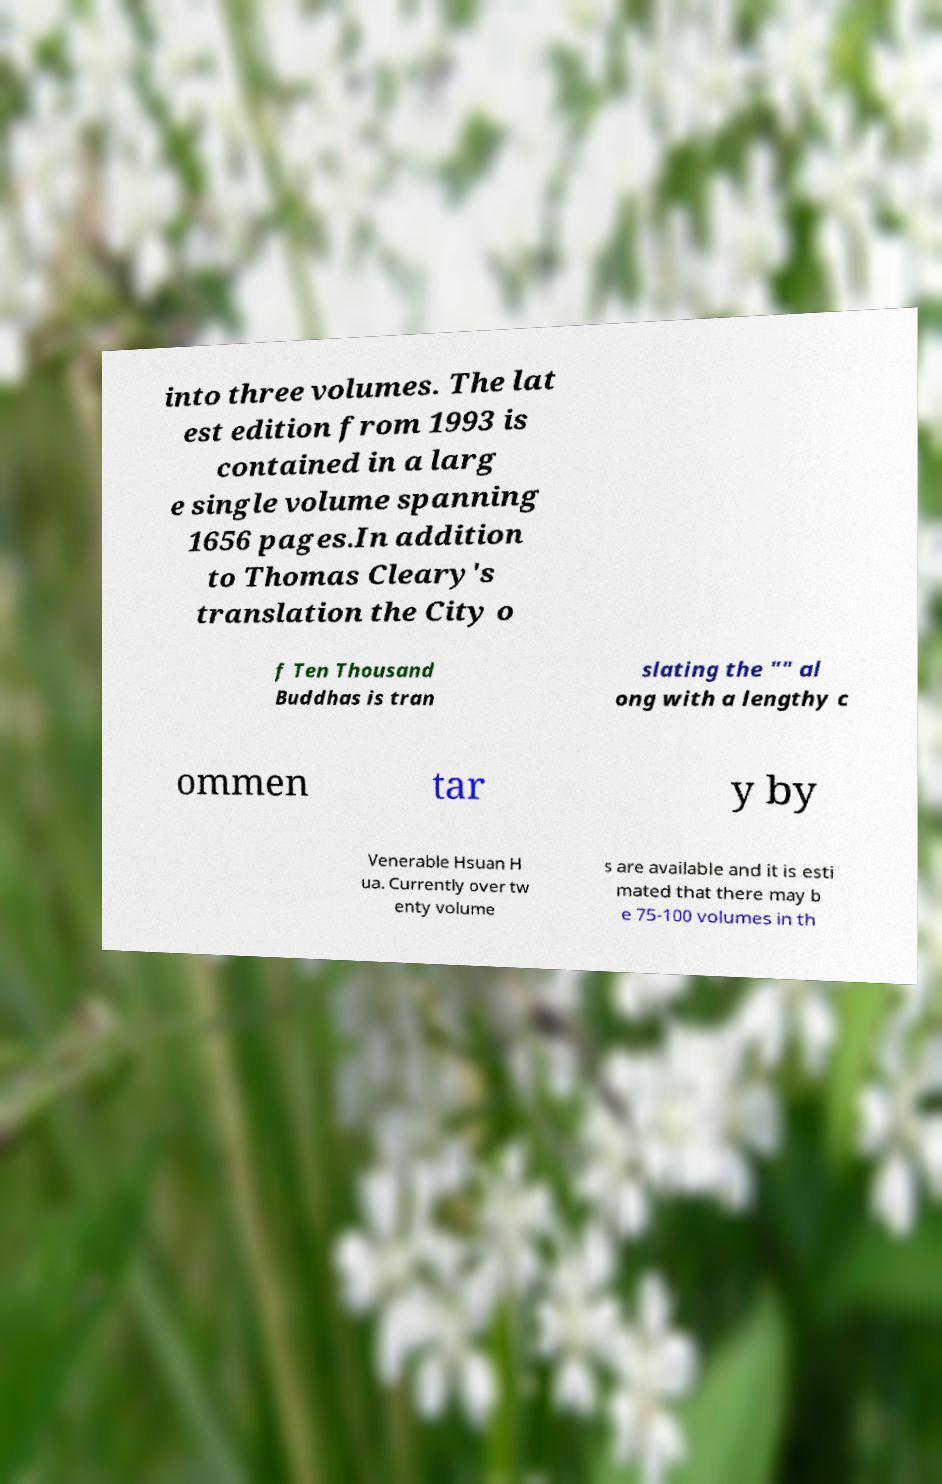What messages or text are displayed in this image? I need them in a readable, typed format. into three volumes. The lat est edition from 1993 is contained in a larg e single volume spanning 1656 pages.In addition to Thomas Cleary's translation the City o f Ten Thousand Buddhas is tran slating the "" al ong with a lengthy c ommen tar y by Venerable Hsuan H ua. Currently over tw enty volume s are available and it is esti mated that there may b e 75-100 volumes in th 